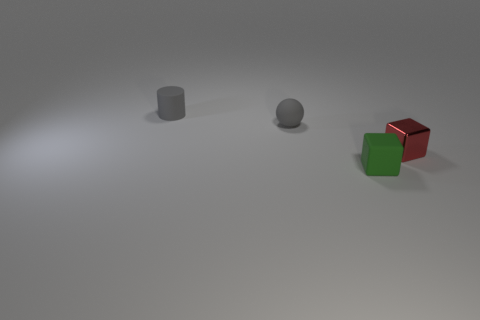Add 1 big shiny balls. How many objects exist? 5 Subtract all cylinders. How many objects are left? 3 Add 2 tiny green matte things. How many tiny green matte things are left? 3 Add 4 small brown metal objects. How many small brown metal objects exist? 4 Subtract 0 blue cubes. How many objects are left? 4 Subtract all large blue cubes. Subtract all tiny gray spheres. How many objects are left? 3 